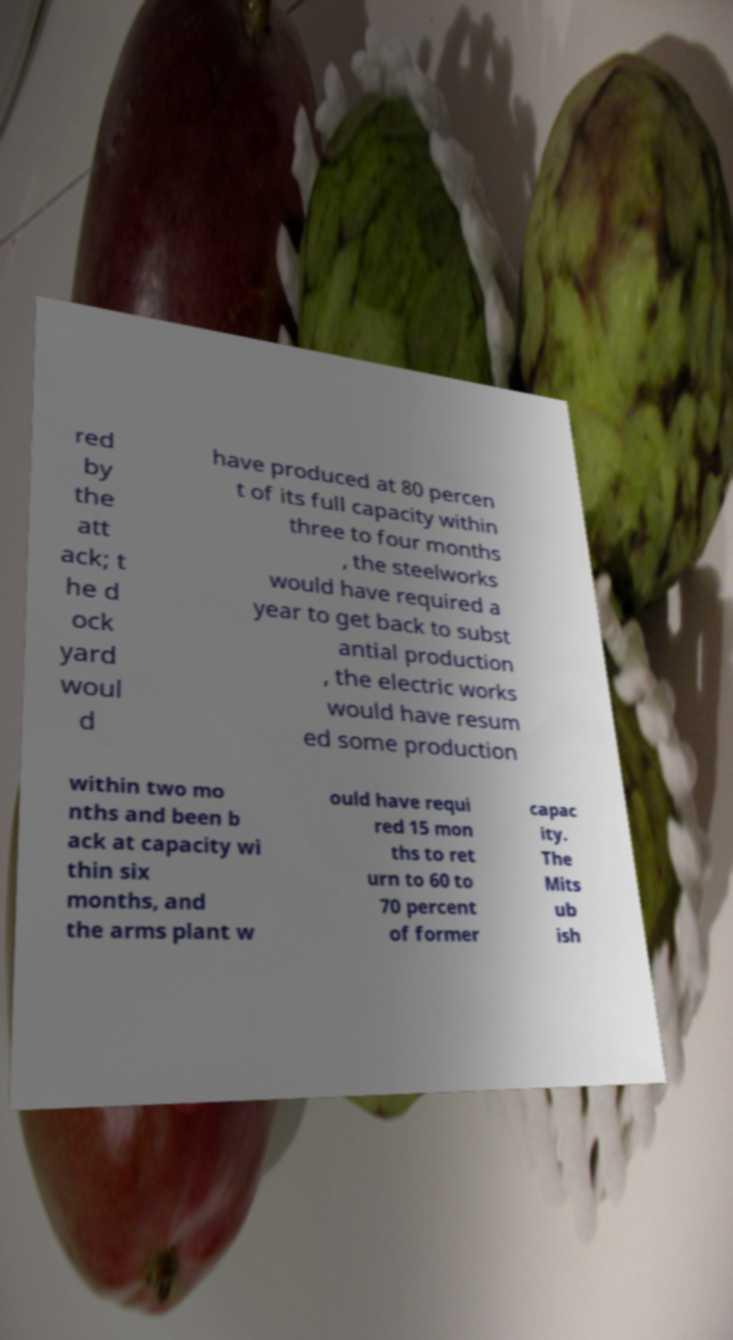I need the written content from this picture converted into text. Can you do that? red by the att ack; t he d ock yard woul d have produced at 80 percen t of its full capacity within three to four months , the steelworks would have required a year to get back to subst antial production , the electric works would have resum ed some production within two mo nths and been b ack at capacity wi thin six months, and the arms plant w ould have requi red 15 mon ths to ret urn to 60 to 70 percent of former capac ity. The Mits ub ish 